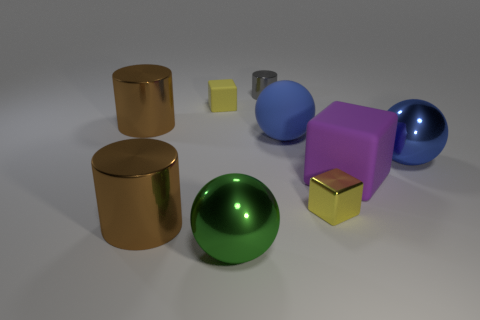Are there any other things that have the same size as the green metallic object?
Ensure brevity in your answer.  Yes. The metallic sphere that is the same color as the big matte sphere is what size?
Your answer should be very brief. Large. There is a block that is on the left side of the small gray cylinder; does it have the same color as the tiny metal cube?
Give a very brief answer. Yes. How many objects are behind the blue rubber ball and on the left side of the tiny gray metallic object?
Offer a very short reply. 2. What number of objects are left of the matte cube to the right of the small matte object?
Your answer should be compact. 7. What number of things are either big brown cylinders behind the large rubber cube or big purple things that are on the right side of the blue rubber thing?
Keep it short and to the point. 2. What material is the large purple thing that is the same shape as the small yellow metal object?
Your answer should be compact. Rubber. How many objects are big balls that are in front of the blue metallic sphere or cylinders?
Your answer should be very brief. 4. What is the shape of the gray thing that is the same material as the green sphere?
Your answer should be compact. Cylinder. How many gray things are the same shape as the purple rubber object?
Offer a terse response. 0. 